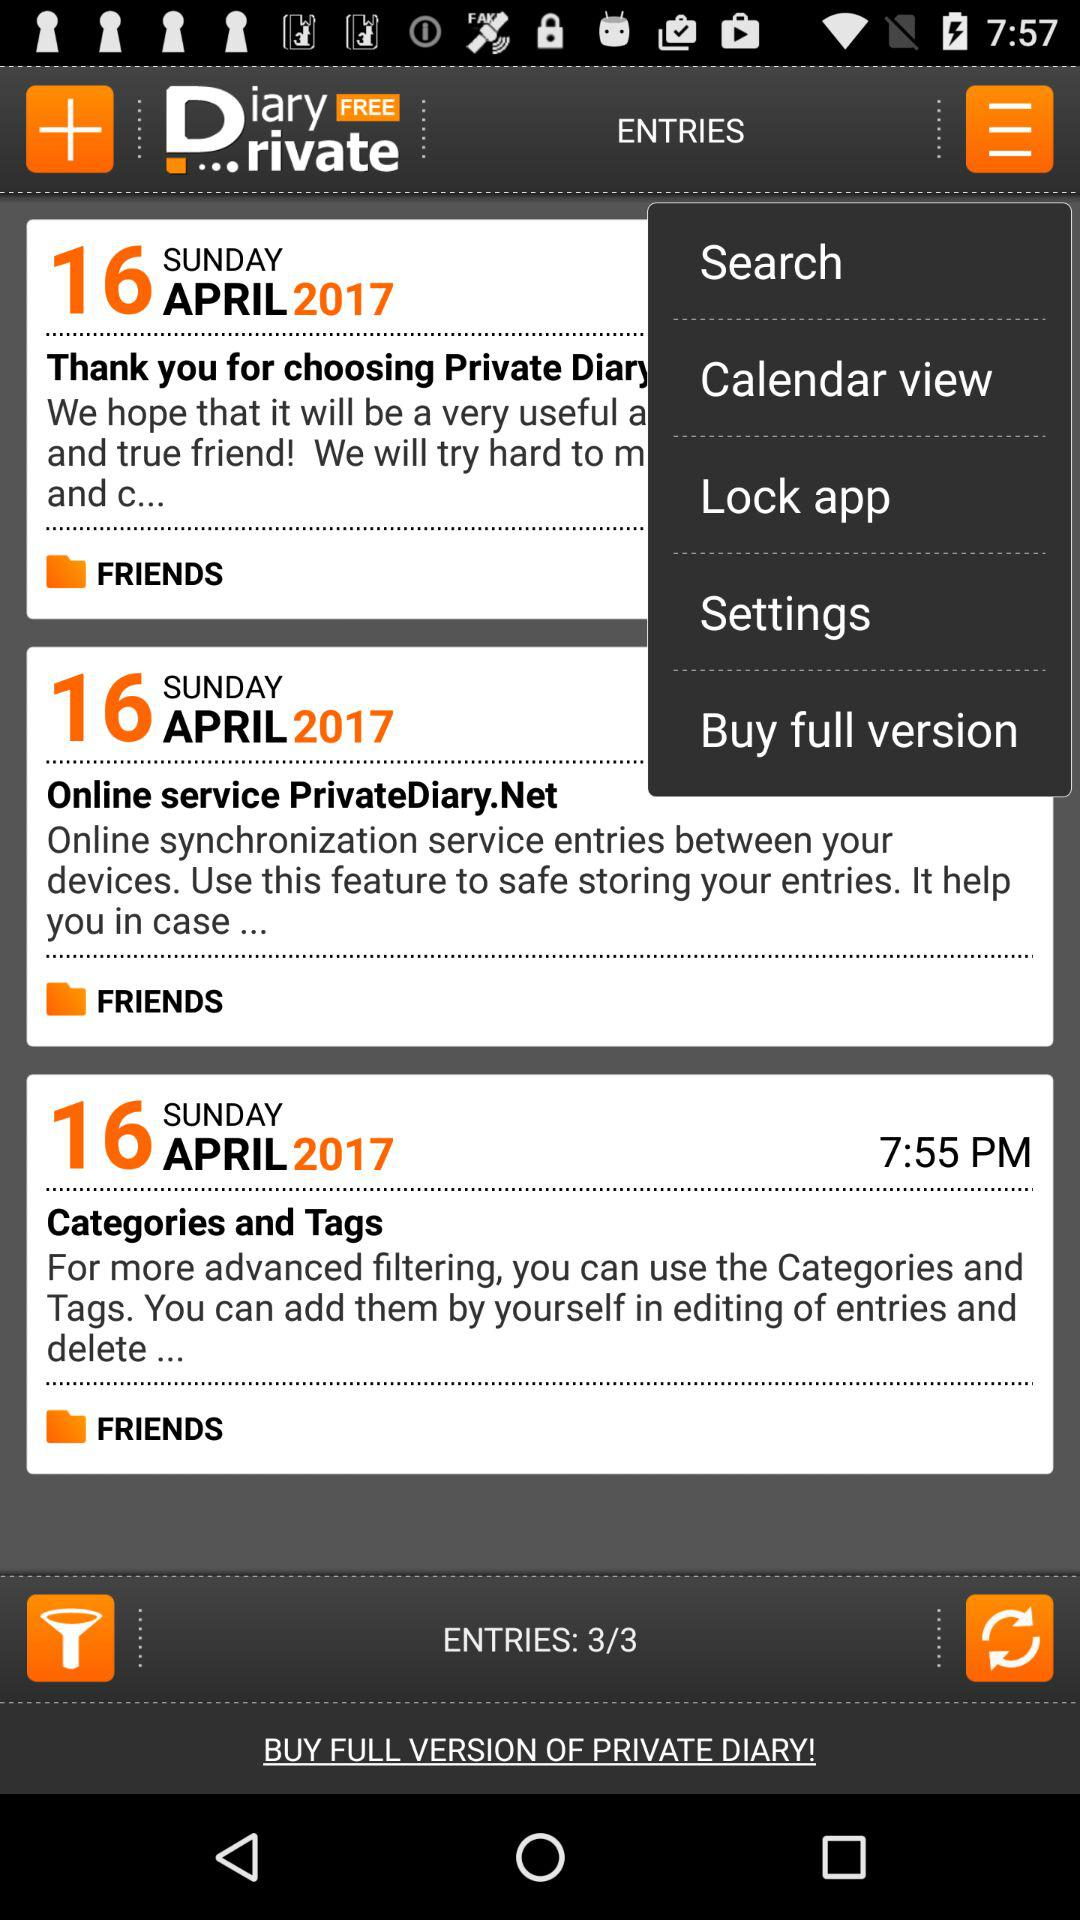How many entries in total are there? There are 3 entries in total. 